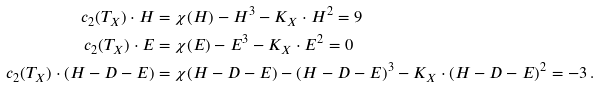<formula> <loc_0><loc_0><loc_500><loc_500>c _ { 2 } ( T _ { X } ) \cdot H & = \chi ( H ) - H ^ { 3 } - K _ { X } \cdot H ^ { 2 } = 9 \\ c _ { 2 } ( T _ { X } ) \cdot E & = \chi ( E ) - E ^ { 3 } - K _ { X } \cdot E ^ { 2 } = 0 \\ c _ { 2 } ( T _ { X } ) \cdot ( H - D - E ) & = \chi ( H - D - E ) - ( H - D - E ) ^ { 3 } - K _ { X } \cdot ( H - D - E ) ^ { 2 } = - 3 \, .</formula> 